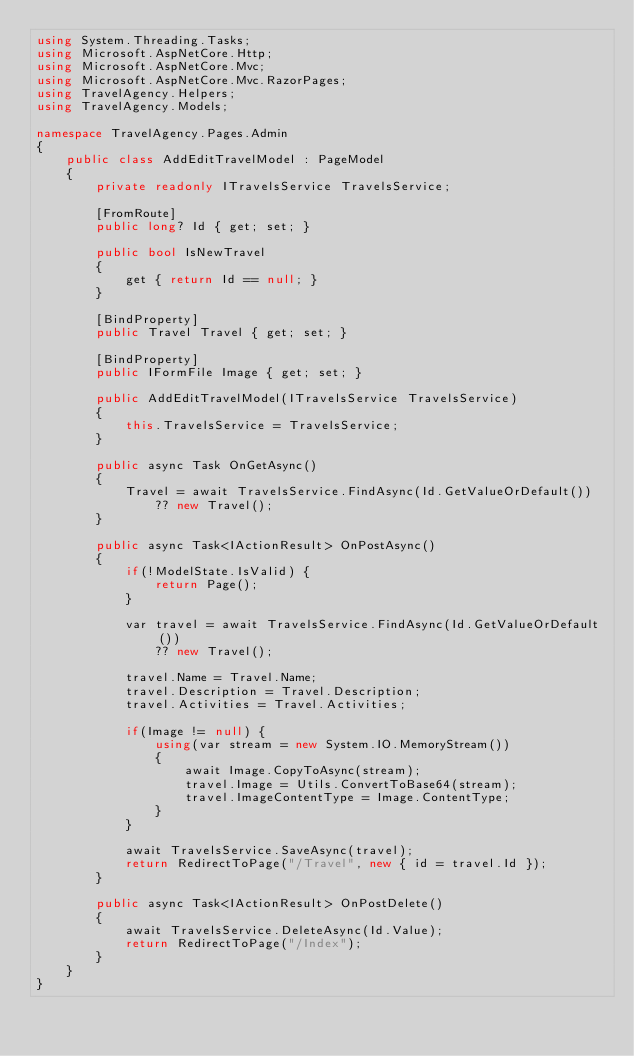<code> <loc_0><loc_0><loc_500><loc_500><_C#_>using System.Threading.Tasks;
using Microsoft.AspNetCore.Http;
using Microsoft.AspNetCore.Mvc;
using Microsoft.AspNetCore.Mvc.RazorPages;
using TravelAgency.Helpers;
using TravelAgency.Models;

namespace TravelAgency.Pages.Admin
{
    public class AddEditTravelModel : PageModel
    {
        private readonly ITravelsService TravelsService;

        [FromRoute]
        public long? Id { get; set; }

        public bool IsNewTravel
        {
            get { return Id == null; }
        }

        [BindProperty]
        public Travel Travel { get; set; }

        [BindProperty]
        public IFormFile Image { get; set; }

        public AddEditTravelModel(ITravelsService TravelsService)
        {
            this.TravelsService = TravelsService;
        }

        public async Task OnGetAsync()
        {
            Travel = await TravelsService.FindAsync(Id.GetValueOrDefault()) 
                ?? new Travel();
        }

        public async Task<IActionResult> OnPostAsync()
        {
            if(!ModelState.IsValid) {
                return Page();
            }

            var travel = await TravelsService.FindAsync(Id.GetValueOrDefault()) 
                ?? new Travel();

            travel.Name = Travel.Name;
            travel.Description = Travel.Description;
            travel.Activities = Travel.Activities;

            if(Image != null) {
                using(var stream = new System.IO.MemoryStream())
                {
                    await Image.CopyToAsync(stream);
                    travel.Image = Utils.ConvertToBase64(stream);
                    travel.ImageContentType = Image.ContentType;
                }
            }

            await TravelsService.SaveAsync(travel);
            return RedirectToPage("/Travel", new { id = travel.Id });
        }

        public async Task<IActionResult> OnPostDelete()
        {
            await TravelsService.DeleteAsync(Id.Value);
            return RedirectToPage("/Index");
        }
    }
}</code> 